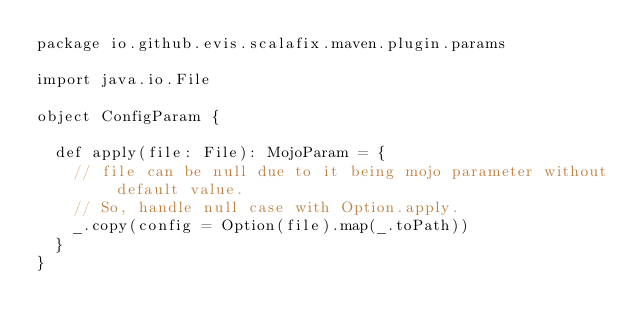Convert code to text. <code><loc_0><loc_0><loc_500><loc_500><_Scala_>package io.github.evis.scalafix.maven.plugin.params

import java.io.File

object ConfigParam {

  def apply(file: File): MojoParam = {
    // file can be null due to it being mojo parameter without default value.
    // So, handle null case with Option.apply.
    _.copy(config = Option(file).map(_.toPath))
  }
}
</code> 